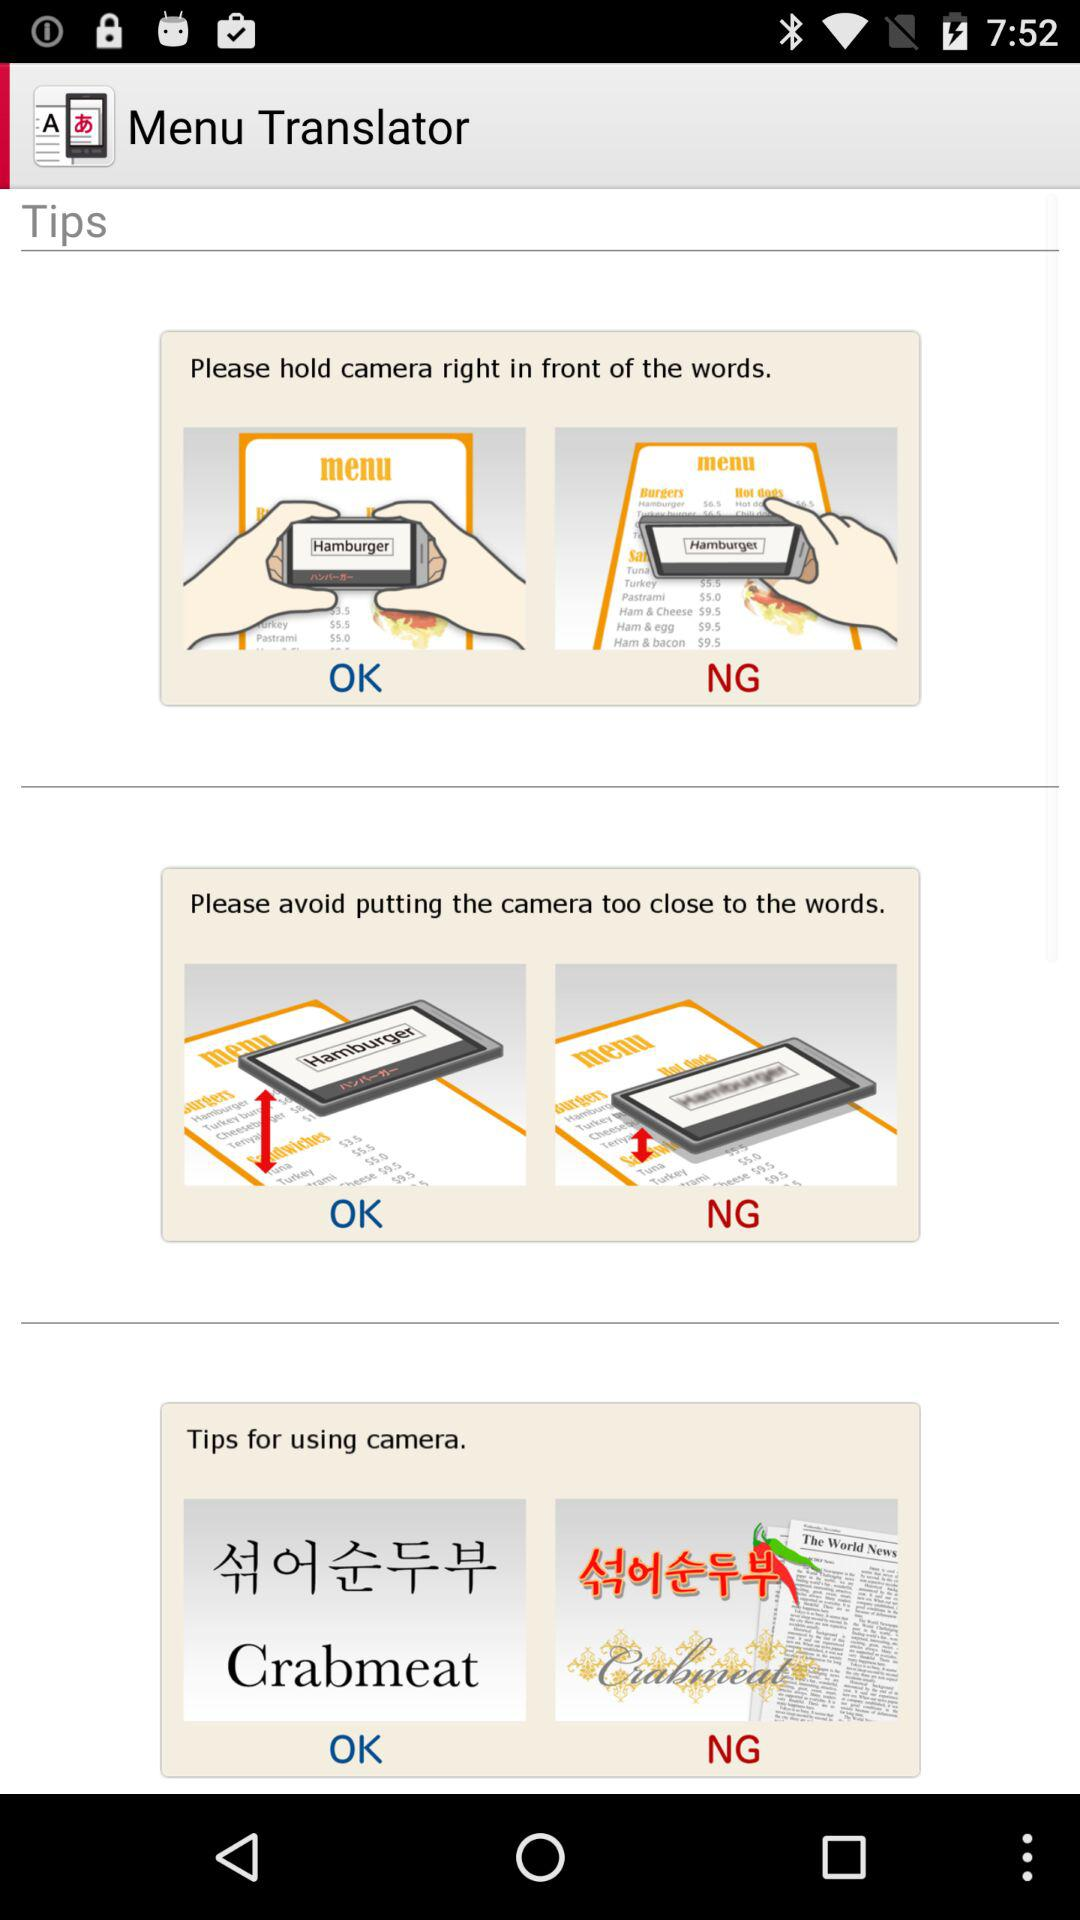Does "NG" stand for "No Good" or "Not Good"?
When the provided information is insufficient, respond with <no answer>. <no answer> 